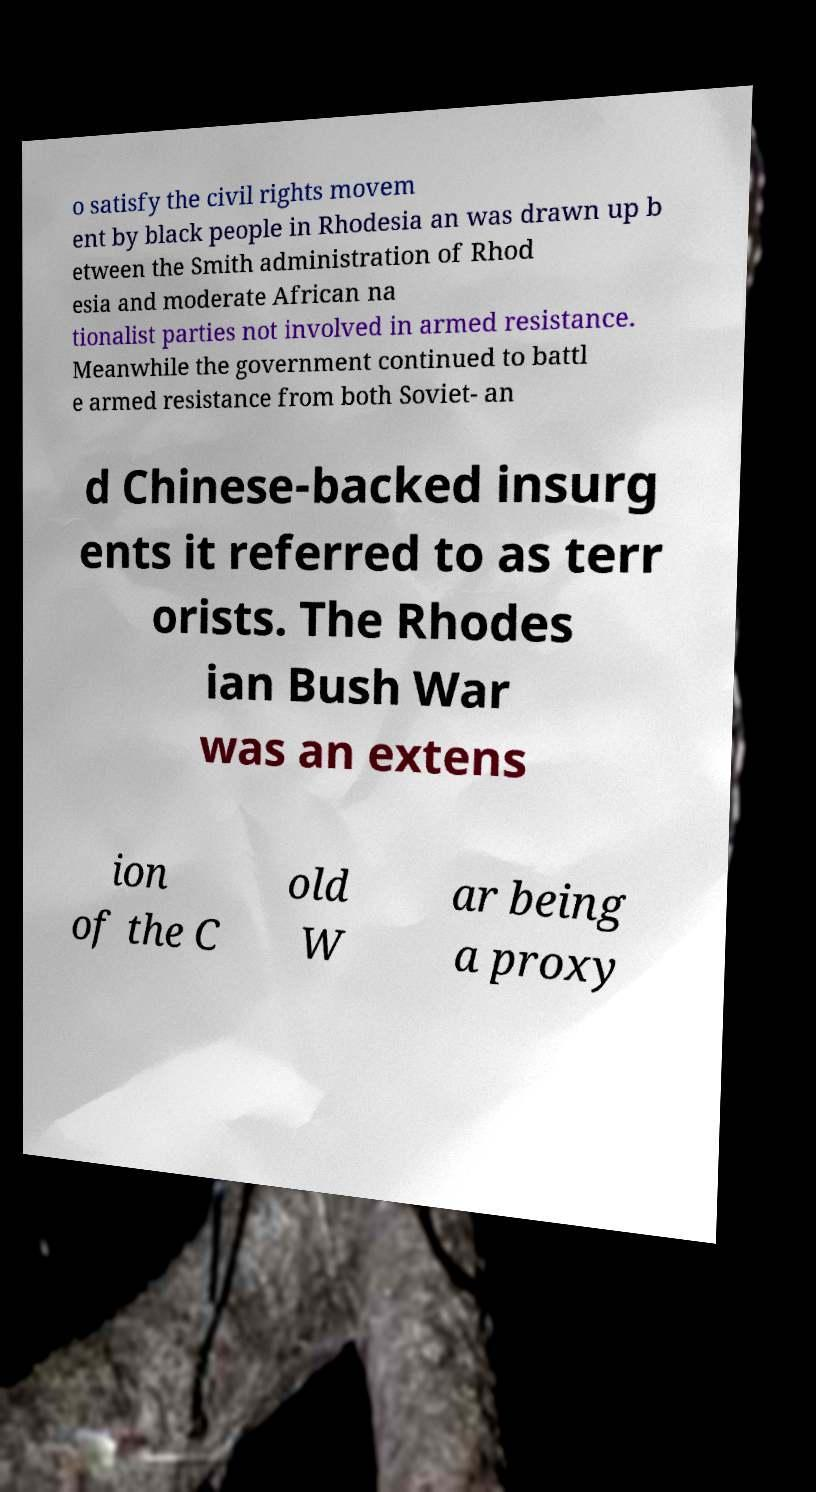For documentation purposes, I need the text within this image transcribed. Could you provide that? o satisfy the civil rights movem ent by black people in Rhodesia an was drawn up b etween the Smith administration of Rhod esia and moderate African na tionalist parties not involved in armed resistance. Meanwhile the government continued to battl e armed resistance from both Soviet- an d Chinese-backed insurg ents it referred to as terr orists. The Rhodes ian Bush War was an extens ion of the C old W ar being a proxy 